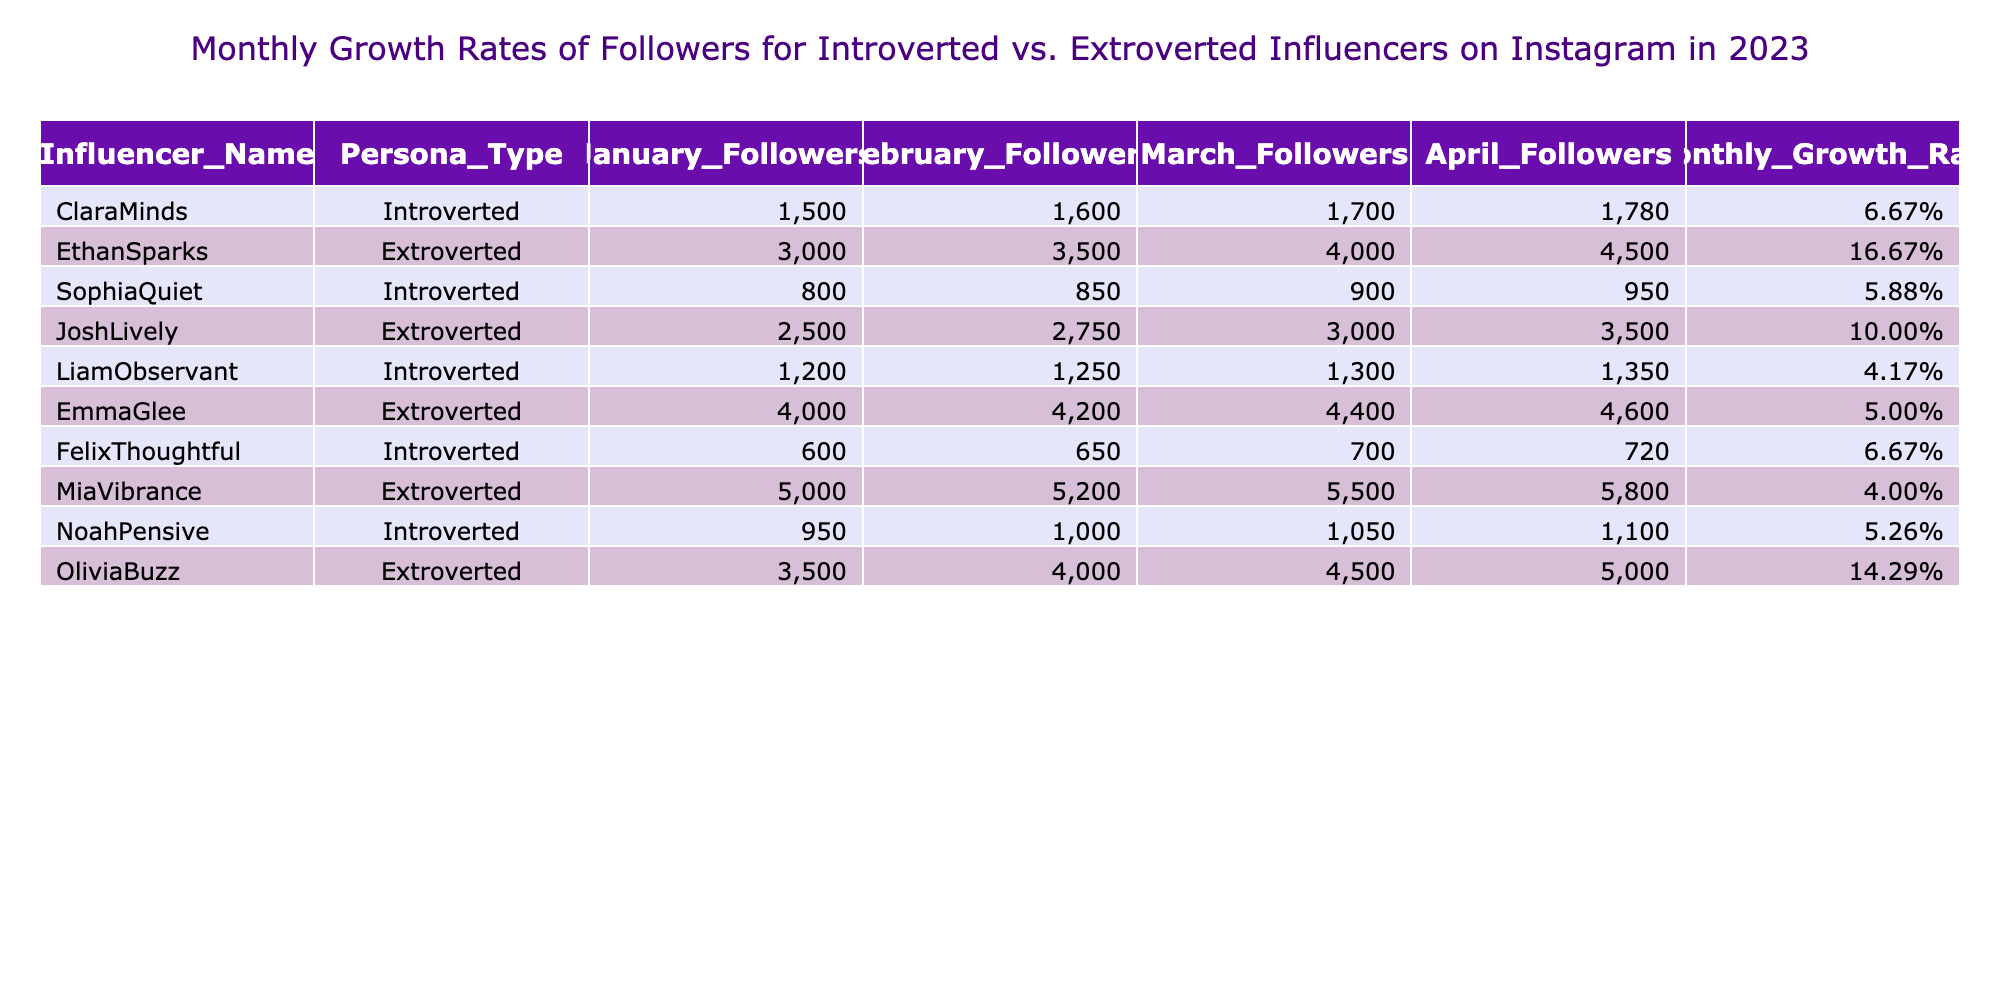What was the monthly growth rate for ClaraMinds in April? Looking at the table, ClaraMinds is listed under the "Monthly Growth Rate" column, and her value for April is 6.67%.
Answer: 6.67% Which influencer experienced the highest monthly growth rate? Reviewing the "Monthly Growth Rate" column, the highest value is for EthanSparks, recorded at 16.67%.
Answer: EthanSparks What is the average monthly growth rate for introverted influencers? The monthly growth rates for introverted influencers are 6.67%, 5.88%, 4.17%, 6.67%, and 5.26%. Adding these gives 28.65%, and dividing by 5 gives an average of 5.73%.
Answer: 5.73% Did MiaVibrance have a higher monthly growth rate than EmmaGlee in March? For March, MiaVibrance's growth rate is 4.00% while EmmaGlee's is 5.00%. Since 4.00% is less than 5.00%, the statement is false.
Answer: No Which introverted influencer had the least followers in January? In the January Followers column, the lowest value is from FelixThoughtful, who had 600 followers.
Answer: FelixThoughtful What is the difference in monthly growth rates between OliviaBuzz and JoshLively? OliviaBuzz has a monthly growth rate of 14.29% and JoshLively has 10.00%. The difference is calculated as 14.29% - 10.00% = 4.29%.
Answer: 4.29% How many followers did NoahPensive have in February? By checking the "February Followers" column, NoahPensive had 1000 followers.
Answer: 1000 Is the monthly growth rate for LiamObservant greater than 5%? LiamObservant has a monthly growth rate of 4.17%, which is less than 5%. Therefore, the answer is false.
Answer: No Which persona type had a higher follower count in April, introverted or extroverted influencers? In April, the extroverted influencers' highest follower count was 5800 (MiaVibrance), while introverted influencers had a maximum of 1780 (ClaraMinds). Extroverted influencers had higher counts.
Answer: Extroverts 